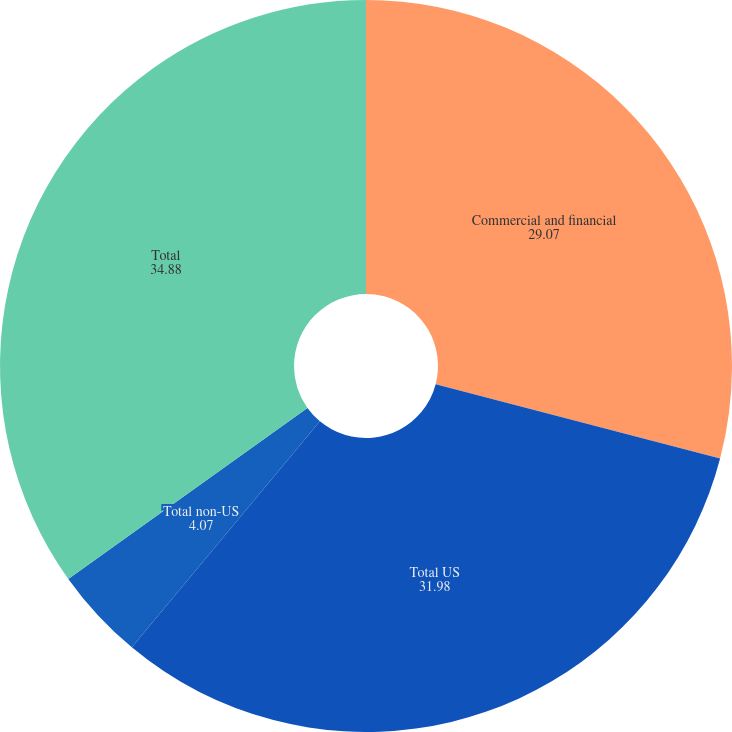Convert chart to OTSL. <chart><loc_0><loc_0><loc_500><loc_500><pie_chart><fcel>Commercial and financial<fcel>Total US<fcel>Total non-US<fcel>Total<nl><fcel>29.07%<fcel>31.98%<fcel>4.07%<fcel>34.88%<nl></chart> 